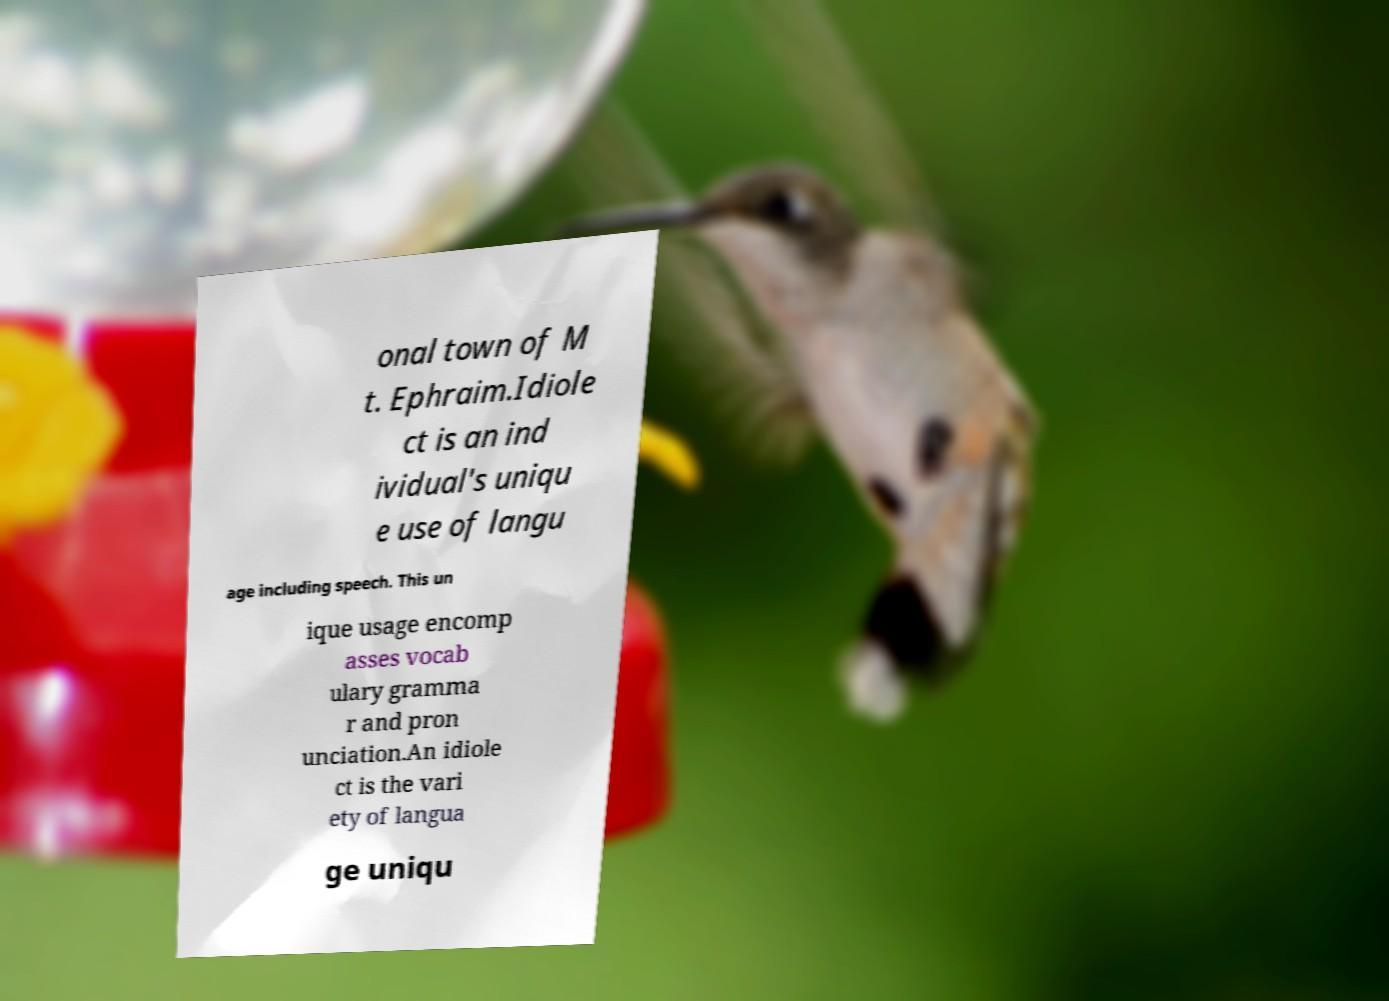Please identify and transcribe the text found in this image. onal town of M t. Ephraim.Idiole ct is an ind ividual's uniqu e use of langu age including speech. This un ique usage encomp asses vocab ulary gramma r and pron unciation.An idiole ct is the vari ety of langua ge uniqu 